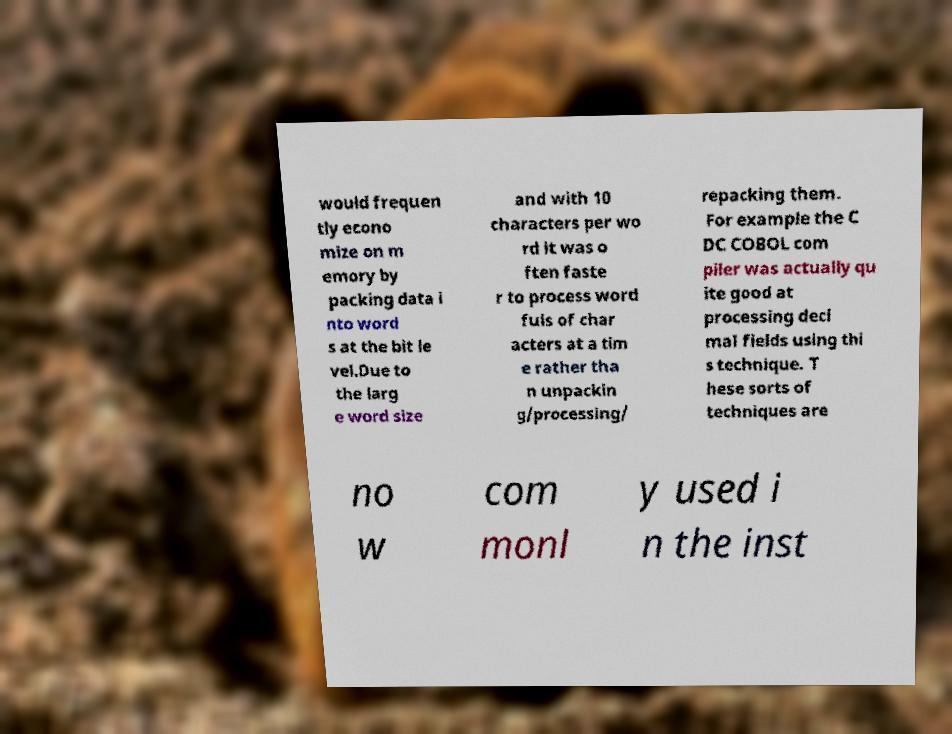Can you accurately transcribe the text from the provided image for me? would frequen tly econo mize on m emory by packing data i nto word s at the bit le vel.Due to the larg e word size and with 10 characters per wo rd it was o ften faste r to process word fuls of char acters at a tim e rather tha n unpackin g/processing/ repacking them. For example the C DC COBOL com piler was actually qu ite good at processing deci mal fields using thi s technique. T hese sorts of techniques are no w com monl y used i n the inst 